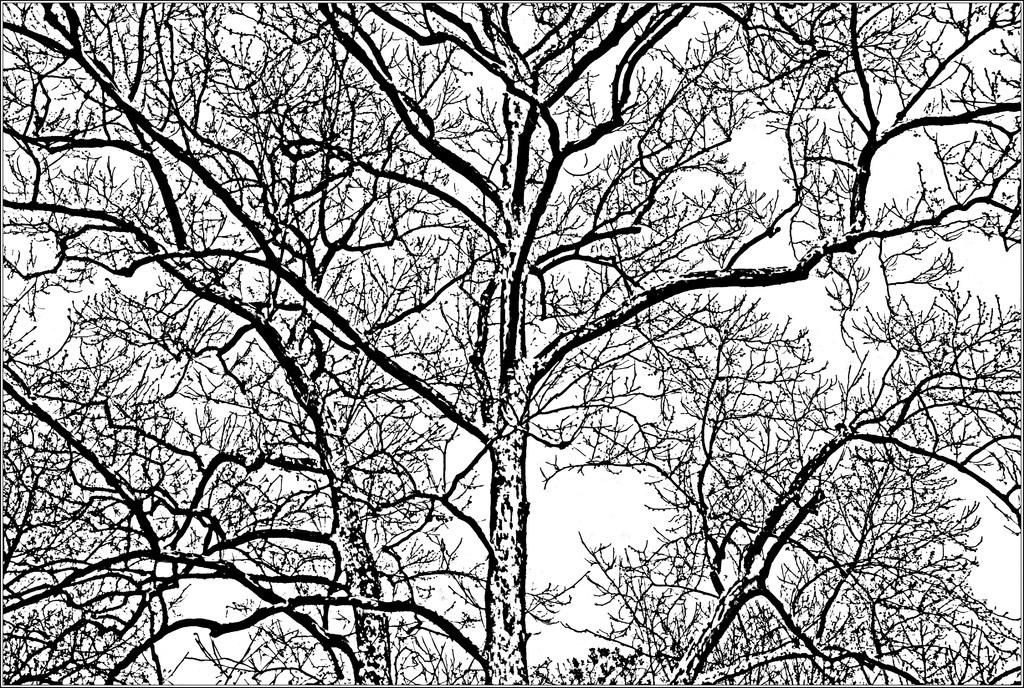What is depicted in the image? There is a drawing of a tree in the image. Can you describe the drawing in more detail? The drawing is of a tree, which may include branches, leaves, and possibly a trunk. What is the medium of the drawing? The facts provided do not specify the medium of the drawing, so we cannot determine if it is a pencil sketch, watercolor, or any other type of drawing. What types of toys are scattered around the wilderness in the image? There is no mention of toys or wilderness in the image, as it only contains a drawing of a tree. 